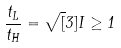<formula> <loc_0><loc_0><loc_500><loc_500>\frac { t _ { L } } { t _ { H } } = \sqrt { [ } 3 ] { I } \geq 1</formula> 